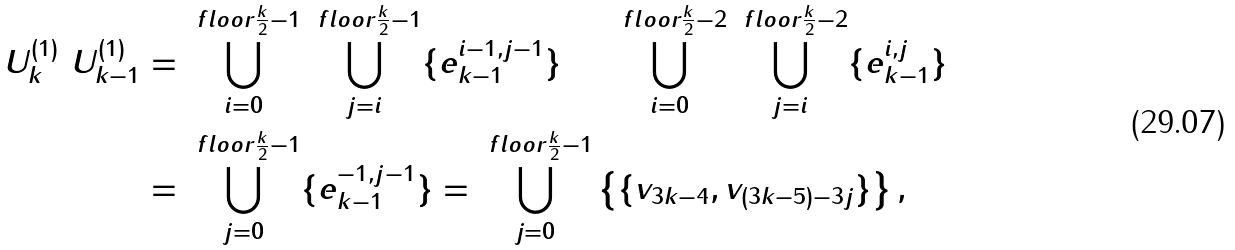<formula> <loc_0><loc_0><loc_500><loc_500>U _ { k } ^ { ( 1 ) } \ U _ { k - 1 } ^ { ( 1 ) } & = \bigcup _ { i = 0 } ^ { \ f l o o r { \frac { k } { 2 } } - 1 } \bigcup _ { j = i } ^ { \ f l o o r { \frac { k } { 2 } } - 1 } \{ e _ { k - 1 } ^ { i - 1 , j - 1 } \} \quad \ \bigcup _ { i = 0 } ^ { \ f l o o r { \frac { k } { 2 } } - 2 } \bigcup _ { j = i } ^ { \ f l o o r { \frac { k } { 2 } } - 2 } \{ e _ { k - 1 } ^ { i , j } \} \\ & = \bigcup _ { j = 0 } ^ { \ f l o o r { \frac { k } { 2 } } - 1 } \{ e _ { k - 1 } ^ { - 1 , j - 1 } \} = \bigcup _ { j = 0 } ^ { \ f l o o r { \frac { k } { 2 } } - 1 } \left \{ \{ v _ { 3 k - 4 } , v _ { ( 3 k - 5 ) - 3 j } \} \right \} ,</formula> 